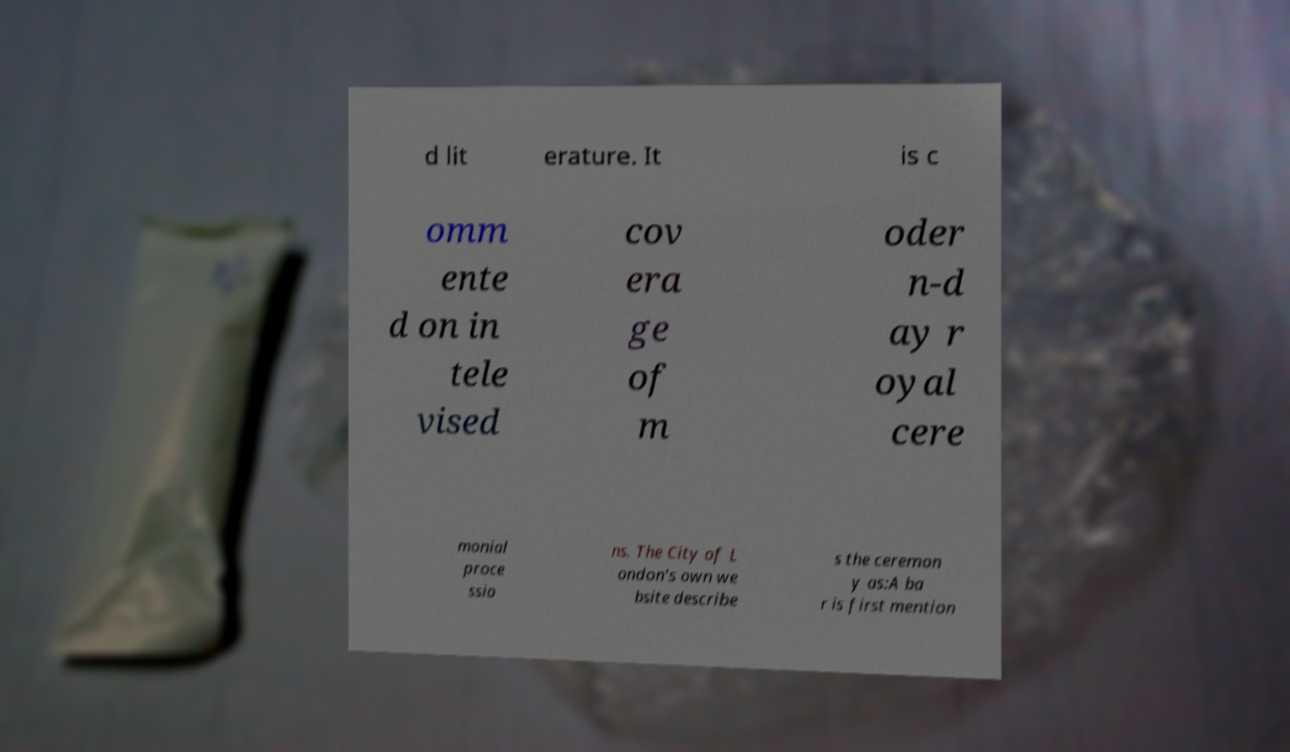Please identify and transcribe the text found in this image. d lit erature. It is c omm ente d on in tele vised cov era ge of m oder n-d ay r oyal cere monial proce ssio ns. The City of L ondon's own we bsite describe s the ceremon y as:A ba r is first mention 